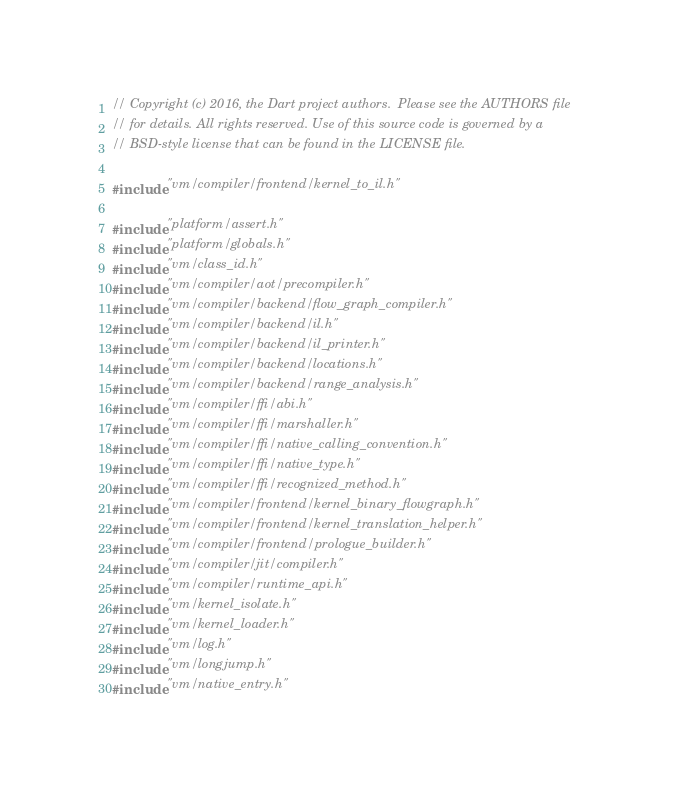Convert code to text. <code><loc_0><loc_0><loc_500><loc_500><_C++_>// Copyright (c) 2016, the Dart project authors.  Please see the AUTHORS file
// for details. All rights reserved. Use of this source code is governed by a
// BSD-style license that can be found in the LICENSE file.

#include "vm/compiler/frontend/kernel_to_il.h"

#include "platform/assert.h"
#include "platform/globals.h"
#include "vm/class_id.h"
#include "vm/compiler/aot/precompiler.h"
#include "vm/compiler/backend/flow_graph_compiler.h"
#include "vm/compiler/backend/il.h"
#include "vm/compiler/backend/il_printer.h"
#include "vm/compiler/backend/locations.h"
#include "vm/compiler/backend/range_analysis.h"
#include "vm/compiler/ffi/abi.h"
#include "vm/compiler/ffi/marshaller.h"
#include "vm/compiler/ffi/native_calling_convention.h"
#include "vm/compiler/ffi/native_type.h"
#include "vm/compiler/ffi/recognized_method.h"
#include "vm/compiler/frontend/kernel_binary_flowgraph.h"
#include "vm/compiler/frontend/kernel_translation_helper.h"
#include "vm/compiler/frontend/prologue_builder.h"
#include "vm/compiler/jit/compiler.h"
#include "vm/compiler/runtime_api.h"
#include "vm/kernel_isolate.h"
#include "vm/kernel_loader.h"
#include "vm/log.h"
#include "vm/longjump.h"
#include "vm/native_entry.h"</code> 